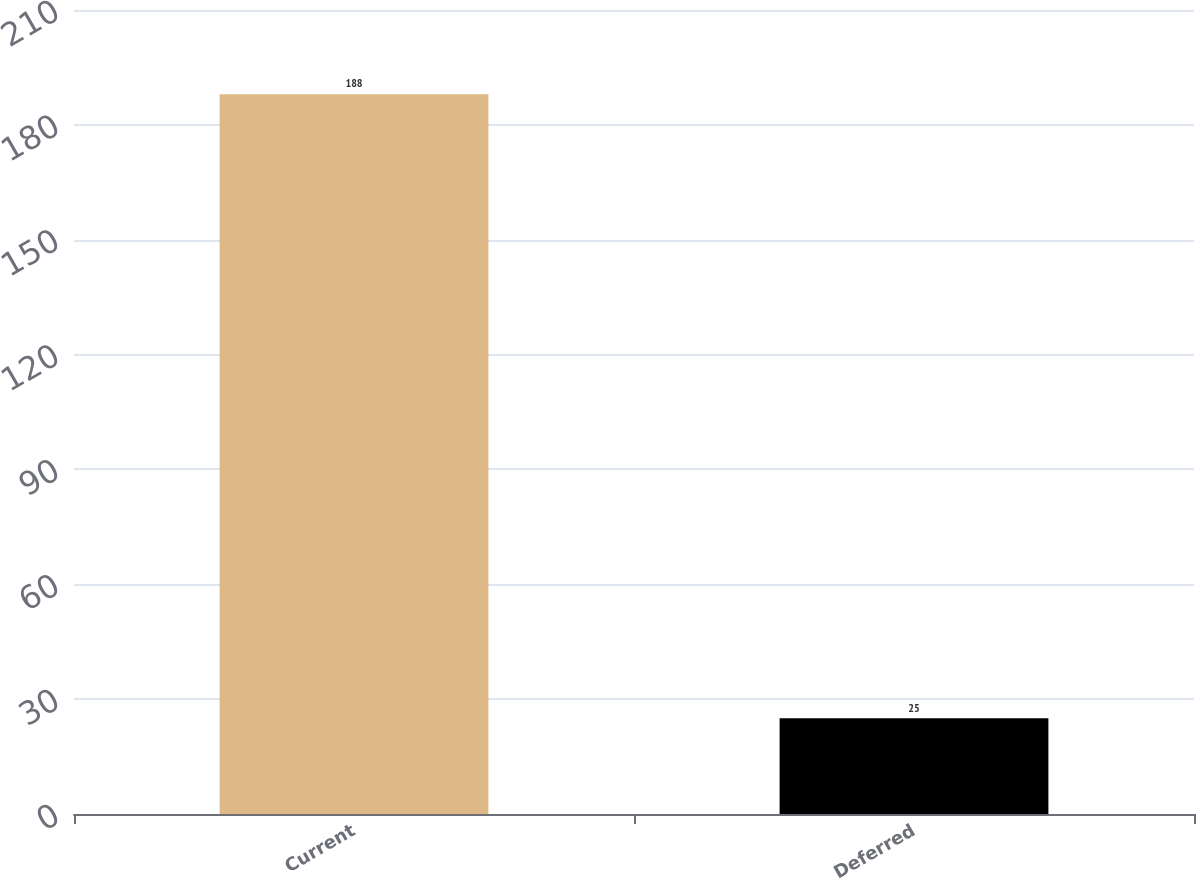<chart> <loc_0><loc_0><loc_500><loc_500><bar_chart><fcel>Current<fcel>Deferred<nl><fcel>188<fcel>25<nl></chart> 